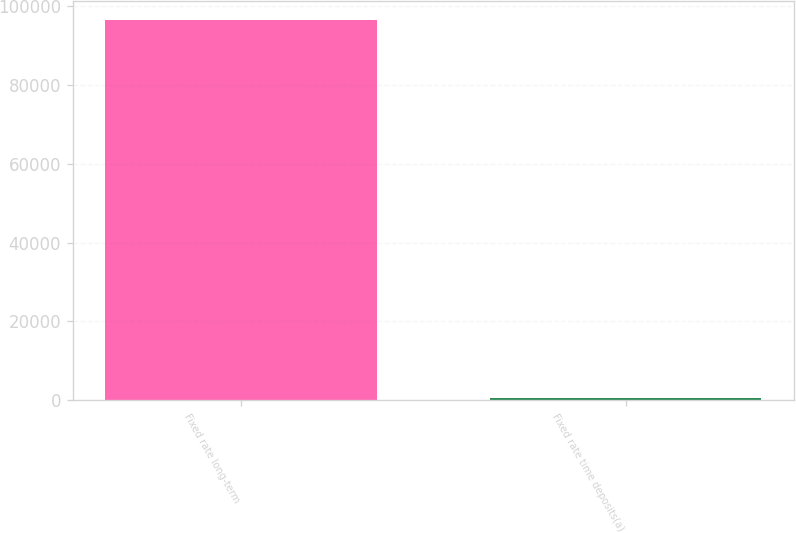Convert chart to OTSL. <chart><loc_0><loc_0><loc_500><loc_500><bar_chart><fcel>Fixed rate long-term<fcel>Fixed rate time deposits(a)<nl><fcel>96637<fcel>503<nl></chart> 